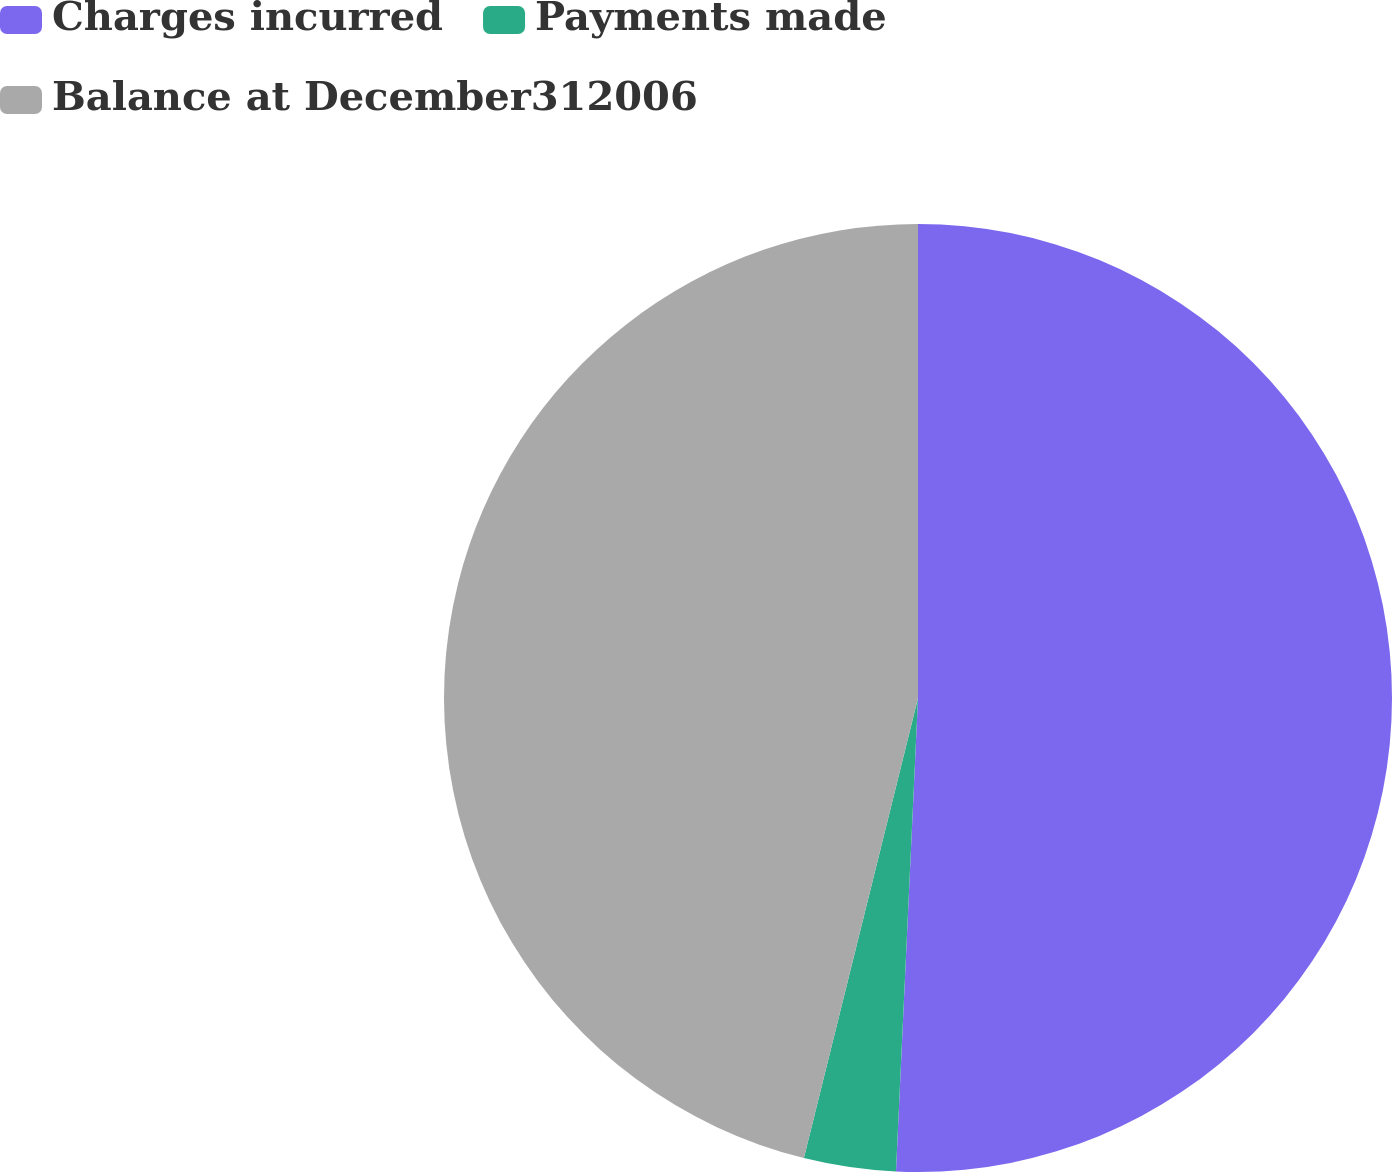Convert chart. <chart><loc_0><loc_0><loc_500><loc_500><pie_chart><fcel>Charges incurred<fcel>Payments made<fcel>Balance at December312006<nl><fcel>50.74%<fcel>3.13%<fcel>46.13%<nl></chart> 